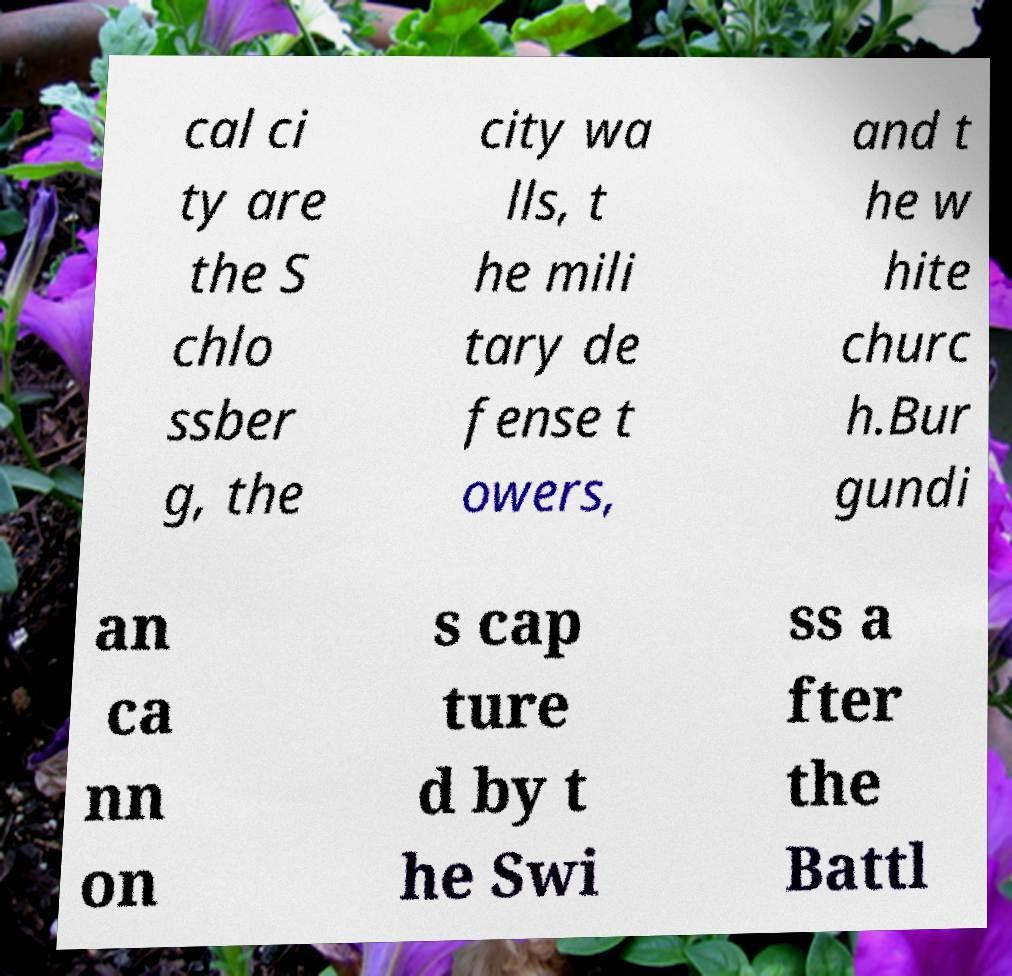Please identify and transcribe the text found in this image. cal ci ty are the S chlo ssber g, the city wa lls, t he mili tary de fense t owers, and t he w hite churc h.Bur gundi an ca nn on s cap ture d by t he Swi ss a fter the Battl 